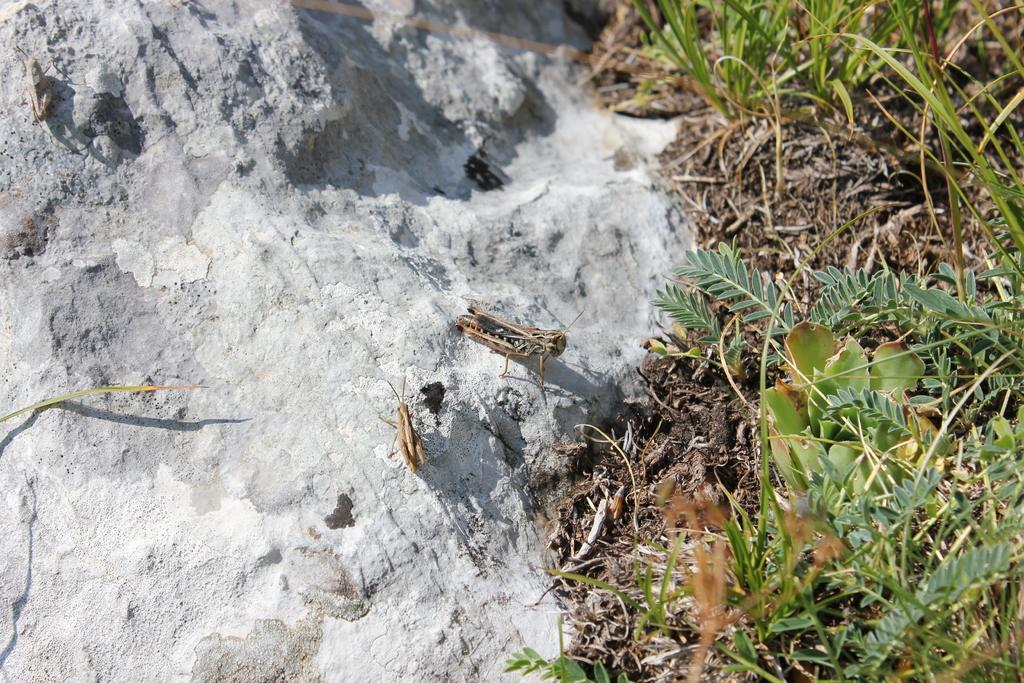What type of creatures can be seen on the stones in the image? There are insects on the stones in the image. Where else can insects be found in the image? Insects can also be found on the ground in the image. What type of lettuce is growing near the hydrant in the image? There is no lettuce or hydrant present in the image; it only features insects on stones and the ground. 